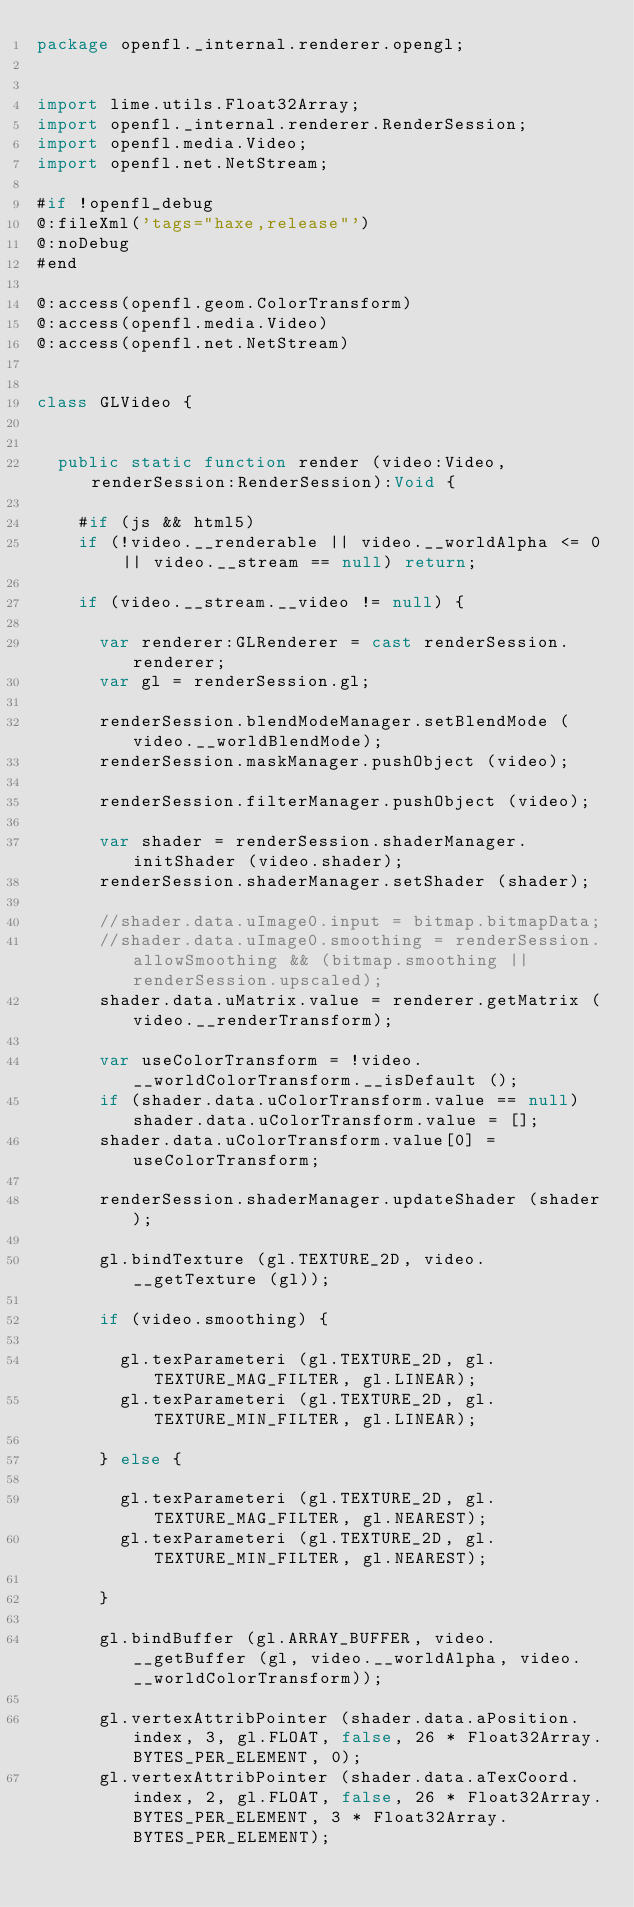<code> <loc_0><loc_0><loc_500><loc_500><_Haxe_>package openfl._internal.renderer.opengl;


import lime.utils.Float32Array;
import openfl._internal.renderer.RenderSession;
import openfl.media.Video;
import openfl.net.NetStream;

#if !openfl_debug
@:fileXml('tags="haxe,release"')
@:noDebug
#end

@:access(openfl.geom.ColorTransform)
@:access(openfl.media.Video)
@:access(openfl.net.NetStream)


class GLVideo {
	
	
	public static function render (video:Video, renderSession:RenderSession):Void {
		
		#if (js && html5)
		if (!video.__renderable || video.__worldAlpha <= 0 || video.__stream == null) return;
		
		if (video.__stream.__video != null) {
			
			var renderer:GLRenderer = cast renderSession.renderer;
			var gl = renderSession.gl;
			
			renderSession.blendModeManager.setBlendMode (video.__worldBlendMode);
			renderSession.maskManager.pushObject (video);
			
			renderSession.filterManager.pushObject (video);
			
			var shader = renderSession.shaderManager.initShader (video.shader);
			renderSession.shaderManager.setShader (shader);
			
			//shader.data.uImage0.input = bitmap.bitmapData;
			//shader.data.uImage0.smoothing = renderSession.allowSmoothing && (bitmap.smoothing || renderSession.upscaled);
			shader.data.uMatrix.value = renderer.getMatrix (video.__renderTransform);
			
			var useColorTransform = !video.__worldColorTransform.__isDefault ();
			if (shader.data.uColorTransform.value == null) shader.data.uColorTransform.value = [];
			shader.data.uColorTransform.value[0] = useColorTransform;
			
			renderSession.shaderManager.updateShader (shader);
			
			gl.bindTexture (gl.TEXTURE_2D, video.__getTexture (gl));
			
			if (video.smoothing) {
				
				gl.texParameteri (gl.TEXTURE_2D, gl.TEXTURE_MAG_FILTER, gl.LINEAR);
				gl.texParameteri (gl.TEXTURE_2D, gl.TEXTURE_MIN_FILTER, gl.LINEAR);
				
			} else {
				
				gl.texParameteri (gl.TEXTURE_2D, gl.TEXTURE_MAG_FILTER, gl.NEAREST);
				gl.texParameteri (gl.TEXTURE_2D, gl.TEXTURE_MIN_FILTER, gl.NEAREST);
				
			}
			
			gl.bindBuffer (gl.ARRAY_BUFFER, video.__getBuffer (gl, video.__worldAlpha, video.__worldColorTransform));
			
			gl.vertexAttribPointer (shader.data.aPosition.index, 3, gl.FLOAT, false, 26 * Float32Array.BYTES_PER_ELEMENT, 0);
			gl.vertexAttribPointer (shader.data.aTexCoord.index, 2, gl.FLOAT, false, 26 * Float32Array.BYTES_PER_ELEMENT, 3 * Float32Array.BYTES_PER_ELEMENT);</code> 